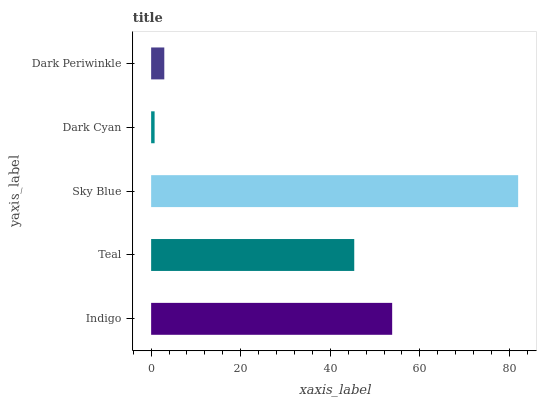Is Dark Cyan the minimum?
Answer yes or no. Yes. Is Sky Blue the maximum?
Answer yes or no. Yes. Is Teal the minimum?
Answer yes or no. No. Is Teal the maximum?
Answer yes or no. No. Is Indigo greater than Teal?
Answer yes or no. Yes. Is Teal less than Indigo?
Answer yes or no. Yes. Is Teal greater than Indigo?
Answer yes or no. No. Is Indigo less than Teal?
Answer yes or no. No. Is Teal the high median?
Answer yes or no. Yes. Is Teal the low median?
Answer yes or no. Yes. Is Dark Periwinkle the high median?
Answer yes or no. No. Is Sky Blue the low median?
Answer yes or no. No. 